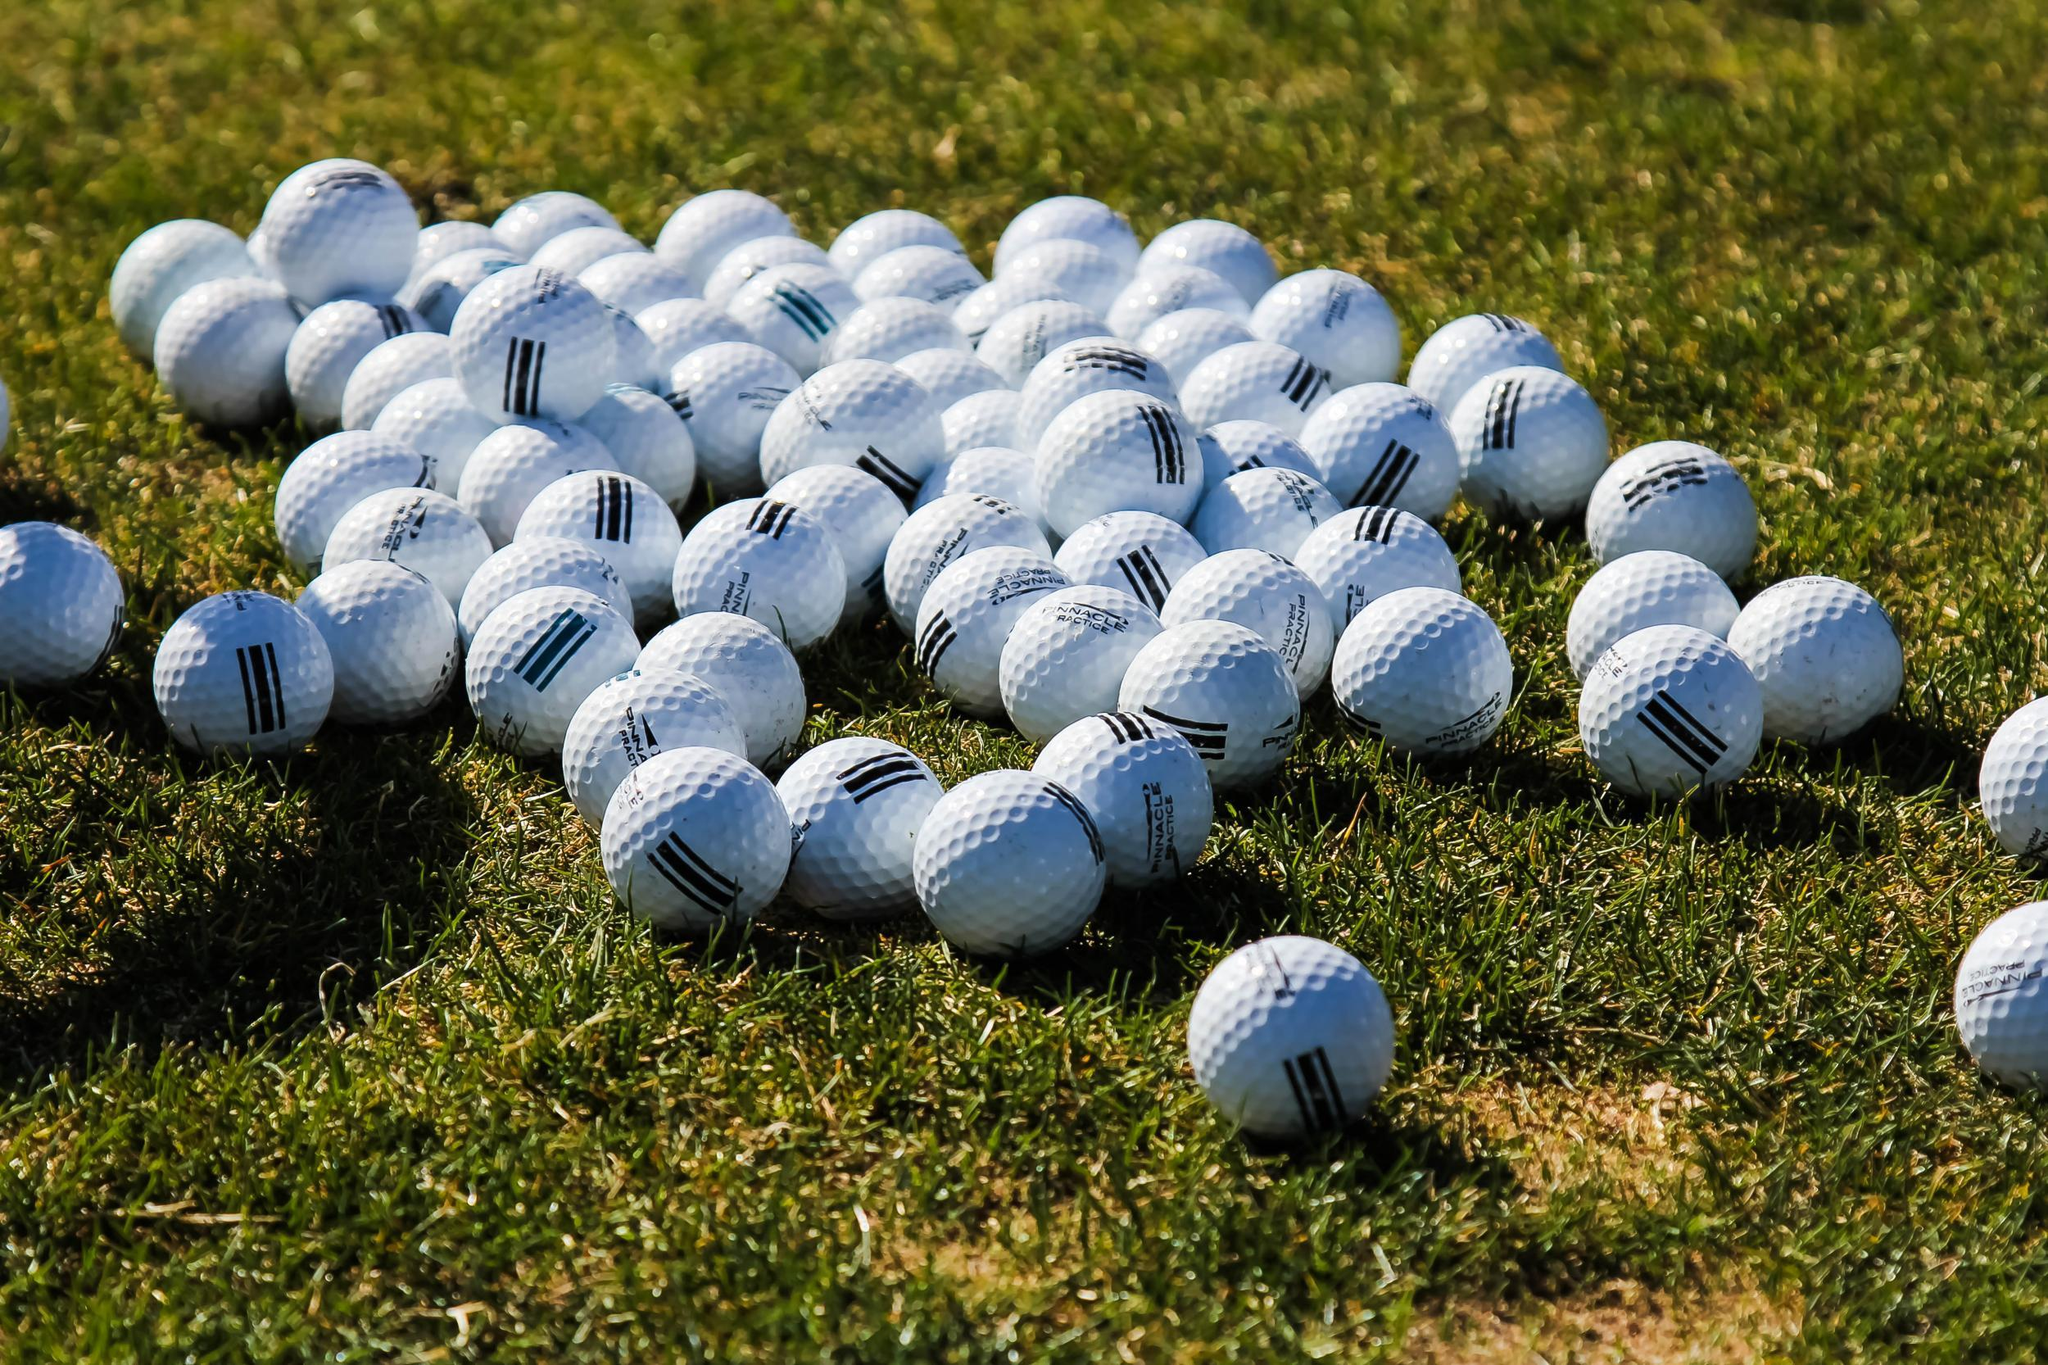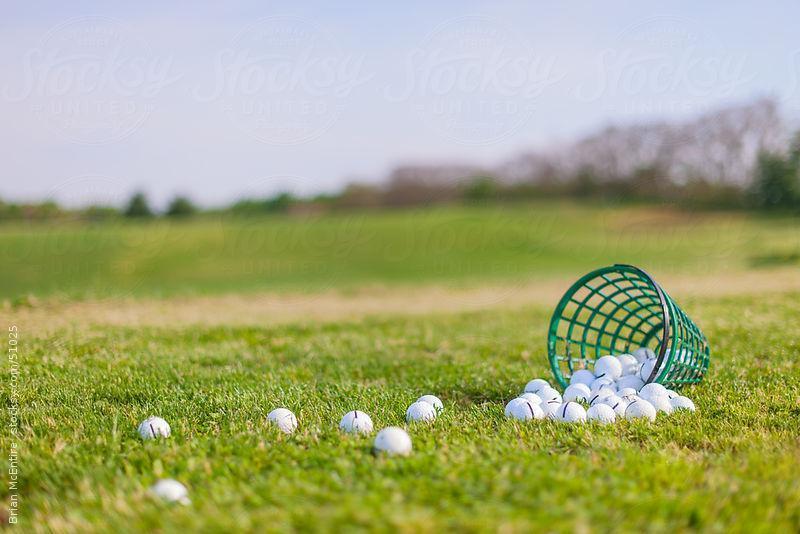The first image is the image on the left, the second image is the image on the right. For the images shown, is this caption "In one photo, a green bucket of golf balls is laying on its side in grass with no golf clubs visible" true? Answer yes or no. Yes. The first image is the image on the left, the second image is the image on the right. Evaluate the accuracy of this statement regarding the images: "A golf club is next to at least one golf ball in one image.". Is it true? Answer yes or no. No. 